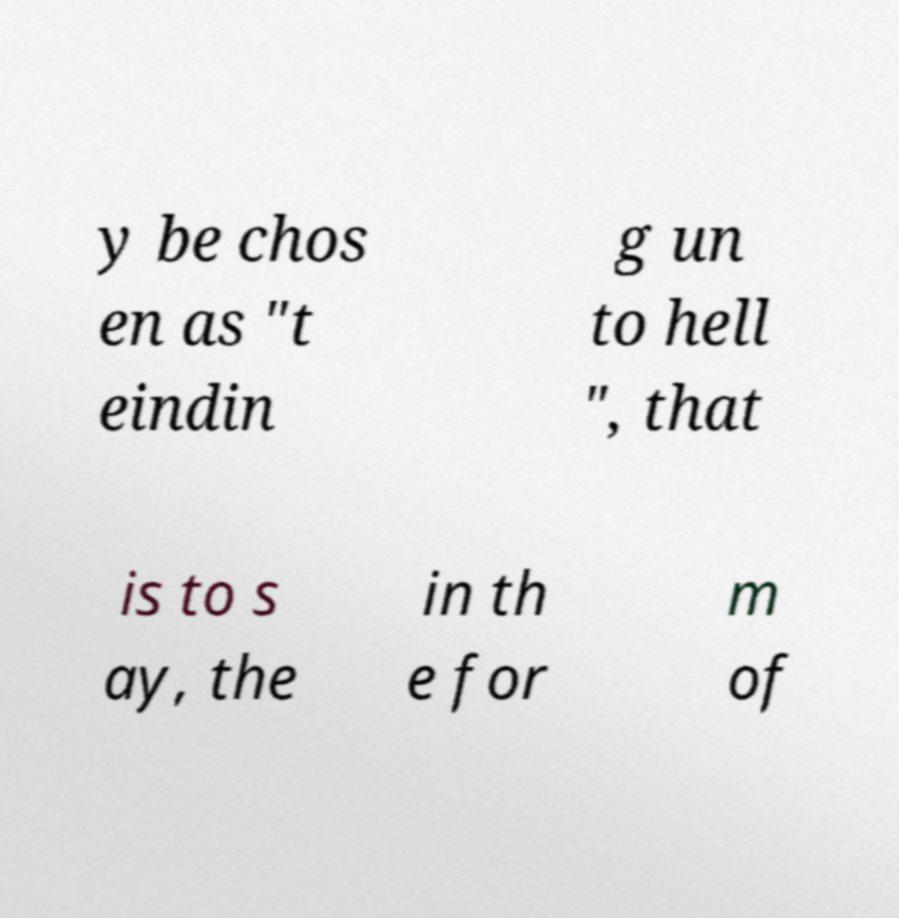Please read and relay the text visible in this image. What does it say? y be chos en as "t eindin g un to hell ", that is to s ay, the in th e for m of 